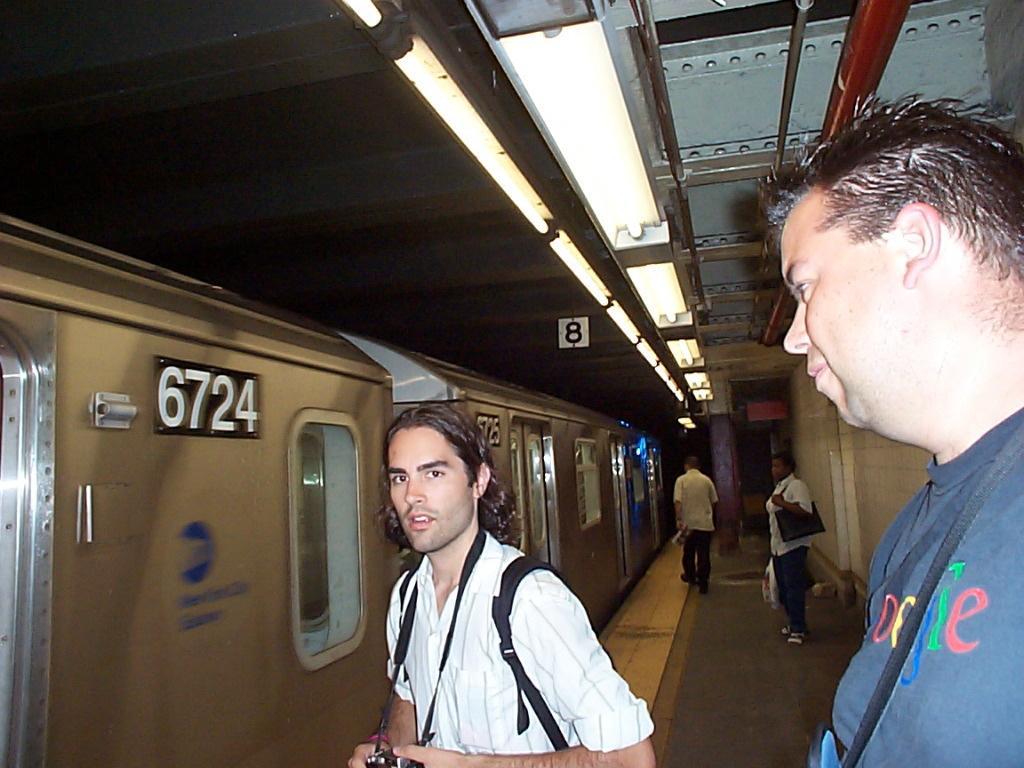Please provide a concise description of this image. In this image in the front there are persons standing and there is a black colour object in the hand of the person. In the background there are persons standing and walking. On the left side there is a train with some numbers written on it. On the top there are lights and there is number board hanging from the roof. 